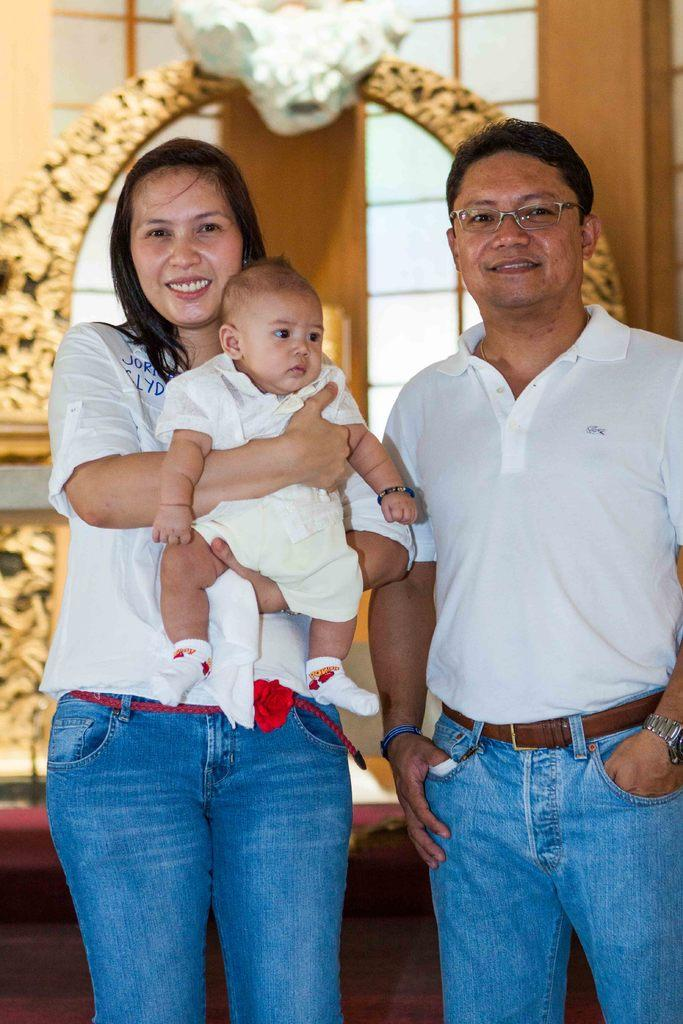How many people are in the image? There are three people in the image: a man, a woman, and a baby. What are the people in the image wearing? The man, woman, and baby are wearing white t-shirts and blue jeans. What can be seen in the background of the image? There is an arch and a window behind the arch in the background of the image. What type of salt can be seen on the road in the image? There is no salt or road present in the image; it features a man, woman, and baby standing in front of an arch and a window. How many thumbs can be seen on the baby's hands in the image? The image does not show the baby's hands or thumbs; it only shows the baby standing with the man and woman. 